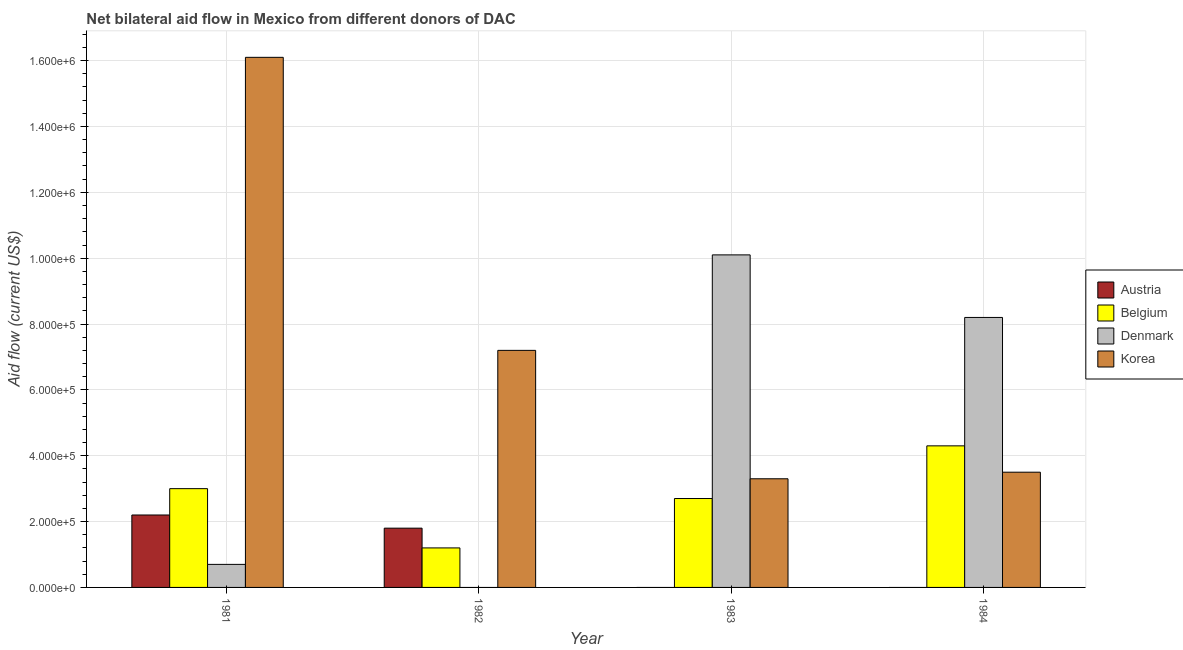How many groups of bars are there?
Provide a succinct answer. 4. Are the number of bars per tick equal to the number of legend labels?
Offer a very short reply. No. How many bars are there on the 4th tick from the right?
Provide a short and direct response. 4. In how many cases, is the number of bars for a given year not equal to the number of legend labels?
Offer a terse response. 3. Across all years, what is the maximum amount of aid given by belgium?
Make the answer very short. 4.30e+05. In which year was the amount of aid given by denmark maximum?
Give a very brief answer. 1983. What is the total amount of aid given by denmark in the graph?
Provide a short and direct response. 1.90e+06. What is the difference between the amount of aid given by korea in 1983 and that in 1984?
Your answer should be compact. -2.00e+04. What is the difference between the amount of aid given by austria in 1982 and the amount of aid given by denmark in 1984?
Offer a very short reply. 1.80e+05. What is the average amount of aid given by austria per year?
Provide a short and direct response. 1.00e+05. In how many years, is the amount of aid given by belgium greater than 600000 US$?
Ensure brevity in your answer.  0. What is the ratio of the amount of aid given by belgium in 1981 to that in 1982?
Your answer should be very brief. 2.5. What is the difference between the highest and the second highest amount of aid given by korea?
Provide a short and direct response. 8.90e+05. What is the difference between the highest and the lowest amount of aid given by denmark?
Your response must be concise. 1.01e+06. Is it the case that in every year, the sum of the amount of aid given by belgium and amount of aid given by korea is greater than the sum of amount of aid given by denmark and amount of aid given by austria?
Offer a very short reply. No. Is it the case that in every year, the sum of the amount of aid given by austria and amount of aid given by belgium is greater than the amount of aid given by denmark?
Your response must be concise. No. Are all the bars in the graph horizontal?
Provide a short and direct response. No. Does the graph contain any zero values?
Ensure brevity in your answer.  Yes. Where does the legend appear in the graph?
Give a very brief answer. Center right. What is the title of the graph?
Your answer should be compact. Net bilateral aid flow in Mexico from different donors of DAC. What is the Aid flow (current US$) of Austria in 1981?
Offer a terse response. 2.20e+05. What is the Aid flow (current US$) of Denmark in 1981?
Your response must be concise. 7.00e+04. What is the Aid flow (current US$) in Korea in 1981?
Offer a very short reply. 1.61e+06. What is the Aid flow (current US$) of Austria in 1982?
Provide a succinct answer. 1.80e+05. What is the Aid flow (current US$) of Korea in 1982?
Your answer should be compact. 7.20e+05. What is the Aid flow (current US$) in Austria in 1983?
Offer a terse response. 0. What is the Aid flow (current US$) in Belgium in 1983?
Your answer should be very brief. 2.70e+05. What is the Aid flow (current US$) in Denmark in 1983?
Your answer should be very brief. 1.01e+06. What is the Aid flow (current US$) of Korea in 1983?
Ensure brevity in your answer.  3.30e+05. What is the Aid flow (current US$) in Austria in 1984?
Your answer should be compact. 0. What is the Aid flow (current US$) in Denmark in 1984?
Give a very brief answer. 8.20e+05. What is the Aid flow (current US$) in Korea in 1984?
Make the answer very short. 3.50e+05. Across all years, what is the maximum Aid flow (current US$) of Belgium?
Provide a succinct answer. 4.30e+05. Across all years, what is the maximum Aid flow (current US$) of Denmark?
Provide a succinct answer. 1.01e+06. Across all years, what is the maximum Aid flow (current US$) in Korea?
Provide a succinct answer. 1.61e+06. Across all years, what is the minimum Aid flow (current US$) of Austria?
Your answer should be compact. 0. Across all years, what is the minimum Aid flow (current US$) in Belgium?
Offer a terse response. 1.20e+05. Across all years, what is the minimum Aid flow (current US$) of Korea?
Your answer should be very brief. 3.30e+05. What is the total Aid flow (current US$) of Austria in the graph?
Ensure brevity in your answer.  4.00e+05. What is the total Aid flow (current US$) in Belgium in the graph?
Offer a terse response. 1.12e+06. What is the total Aid flow (current US$) in Denmark in the graph?
Provide a succinct answer. 1.90e+06. What is the total Aid flow (current US$) in Korea in the graph?
Make the answer very short. 3.01e+06. What is the difference between the Aid flow (current US$) of Belgium in 1981 and that in 1982?
Ensure brevity in your answer.  1.80e+05. What is the difference between the Aid flow (current US$) in Korea in 1981 and that in 1982?
Provide a short and direct response. 8.90e+05. What is the difference between the Aid flow (current US$) in Denmark in 1981 and that in 1983?
Your answer should be very brief. -9.40e+05. What is the difference between the Aid flow (current US$) in Korea in 1981 and that in 1983?
Provide a succinct answer. 1.28e+06. What is the difference between the Aid flow (current US$) in Belgium in 1981 and that in 1984?
Offer a terse response. -1.30e+05. What is the difference between the Aid flow (current US$) of Denmark in 1981 and that in 1984?
Offer a terse response. -7.50e+05. What is the difference between the Aid flow (current US$) in Korea in 1981 and that in 1984?
Provide a succinct answer. 1.26e+06. What is the difference between the Aid flow (current US$) in Korea in 1982 and that in 1983?
Ensure brevity in your answer.  3.90e+05. What is the difference between the Aid flow (current US$) in Belgium in 1982 and that in 1984?
Ensure brevity in your answer.  -3.10e+05. What is the difference between the Aid flow (current US$) in Belgium in 1983 and that in 1984?
Your answer should be compact. -1.60e+05. What is the difference between the Aid flow (current US$) of Korea in 1983 and that in 1984?
Your answer should be very brief. -2.00e+04. What is the difference between the Aid flow (current US$) in Austria in 1981 and the Aid flow (current US$) in Korea in 1982?
Give a very brief answer. -5.00e+05. What is the difference between the Aid flow (current US$) in Belgium in 1981 and the Aid flow (current US$) in Korea in 1982?
Offer a terse response. -4.20e+05. What is the difference between the Aid flow (current US$) of Denmark in 1981 and the Aid flow (current US$) of Korea in 1982?
Offer a terse response. -6.50e+05. What is the difference between the Aid flow (current US$) in Austria in 1981 and the Aid flow (current US$) in Belgium in 1983?
Provide a succinct answer. -5.00e+04. What is the difference between the Aid flow (current US$) in Austria in 1981 and the Aid flow (current US$) in Denmark in 1983?
Your answer should be compact. -7.90e+05. What is the difference between the Aid flow (current US$) of Belgium in 1981 and the Aid flow (current US$) of Denmark in 1983?
Offer a terse response. -7.10e+05. What is the difference between the Aid flow (current US$) of Belgium in 1981 and the Aid flow (current US$) of Korea in 1983?
Give a very brief answer. -3.00e+04. What is the difference between the Aid flow (current US$) of Austria in 1981 and the Aid flow (current US$) of Denmark in 1984?
Offer a very short reply. -6.00e+05. What is the difference between the Aid flow (current US$) of Austria in 1981 and the Aid flow (current US$) of Korea in 1984?
Give a very brief answer. -1.30e+05. What is the difference between the Aid flow (current US$) in Belgium in 1981 and the Aid flow (current US$) in Denmark in 1984?
Make the answer very short. -5.20e+05. What is the difference between the Aid flow (current US$) of Denmark in 1981 and the Aid flow (current US$) of Korea in 1984?
Provide a short and direct response. -2.80e+05. What is the difference between the Aid flow (current US$) of Austria in 1982 and the Aid flow (current US$) of Belgium in 1983?
Your response must be concise. -9.00e+04. What is the difference between the Aid flow (current US$) of Austria in 1982 and the Aid flow (current US$) of Denmark in 1983?
Offer a very short reply. -8.30e+05. What is the difference between the Aid flow (current US$) in Belgium in 1982 and the Aid flow (current US$) in Denmark in 1983?
Ensure brevity in your answer.  -8.90e+05. What is the difference between the Aid flow (current US$) in Austria in 1982 and the Aid flow (current US$) in Denmark in 1984?
Your response must be concise. -6.40e+05. What is the difference between the Aid flow (current US$) in Austria in 1982 and the Aid flow (current US$) in Korea in 1984?
Make the answer very short. -1.70e+05. What is the difference between the Aid flow (current US$) in Belgium in 1982 and the Aid flow (current US$) in Denmark in 1984?
Offer a very short reply. -7.00e+05. What is the difference between the Aid flow (current US$) in Belgium in 1982 and the Aid flow (current US$) in Korea in 1984?
Your answer should be very brief. -2.30e+05. What is the difference between the Aid flow (current US$) in Belgium in 1983 and the Aid flow (current US$) in Denmark in 1984?
Provide a short and direct response. -5.50e+05. What is the difference between the Aid flow (current US$) of Belgium in 1983 and the Aid flow (current US$) of Korea in 1984?
Ensure brevity in your answer.  -8.00e+04. What is the difference between the Aid flow (current US$) of Denmark in 1983 and the Aid flow (current US$) of Korea in 1984?
Ensure brevity in your answer.  6.60e+05. What is the average Aid flow (current US$) in Austria per year?
Your answer should be compact. 1.00e+05. What is the average Aid flow (current US$) in Belgium per year?
Make the answer very short. 2.80e+05. What is the average Aid flow (current US$) in Denmark per year?
Make the answer very short. 4.75e+05. What is the average Aid flow (current US$) in Korea per year?
Provide a succinct answer. 7.52e+05. In the year 1981, what is the difference between the Aid flow (current US$) of Austria and Aid flow (current US$) of Korea?
Your answer should be very brief. -1.39e+06. In the year 1981, what is the difference between the Aid flow (current US$) in Belgium and Aid flow (current US$) in Denmark?
Your answer should be very brief. 2.30e+05. In the year 1981, what is the difference between the Aid flow (current US$) of Belgium and Aid flow (current US$) of Korea?
Ensure brevity in your answer.  -1.31e+06. In the year 1981, what is the difference between the Aid flow (current US$) in Denmark and Aid flow (current US$) in Korea?
Make the answer very short. -1.54e+06. In the year 1982, what is the difference between the Aid flow (current US$) in Austria and Aid flow (current US$) in Korea?
Your answer should be compact. -5.40e+05. In the year 1982, what is the difference between the Aid flow (current US$) in Belgium and Aid flow (current US$) in Korea?
Provide a succinct answer. -6.00e+05. In the year 1983, what is the difference between the Aid flow (current US$) in Belgium and Aid flow (current US$) in Denmark?
Offer a very short reply. -7.40e+05. In the year 1983, what is the difference between the Aid flow (current US$) in Belgium and Aid flow (current US$) in Korea?
Provide a short and direct response. -6.00e+04. In the year 1983, what is the difference between the Aid flow (current US$) of Denmark and Aid flow (current US$) of Korea?
Provide a succinct answer. 6.80e+05. In the year 1984, what is the difference between the Aid flow (current US$) of Belgium and Aid flow (current US$) of Denmark?
Your response must be concise. -3.90e+05. In the year 1984, what is the difference between the Aid flow (current US$) in Belgium and Aid flow (current US$) in Korea?
Offer a terse response. 8.00e+04. In the year 1984, what is the difference between the Aid flow (current US$) of Denmark and Aid flow (current US$) of Korea?
Provide a short and direct response. 4.70e+05. What is the ratio of the Aid flow (current US$) in Austria in 1981 to that in 1982?
Your answer should be compact. 1.22. What is the ratio of the Aid flow (current US$) in Belgium in 1981 to that in 1982?
Give a very brief answer. 2.5. What is the ratio of the Aid flow (current US$) of Korea in 1981 to that in 1982?
Give a very brief answer. 2.24. What is the ratio of the Aid flow (current US$) in Belgium in 1981 to that in 1983?
Offer a very short reply. 1.11. What is the ratio of the Aid flow (current US$) of Denmark in 1981 to that in 1983?
Make the answer very short. 0.07. What is the ratio of the Aid flow (current US$) in Korea in 1981 to that in 1983?
Keep it short and to the point. 4.88. What is the ratio of the Aid flow (current US$) in Belgium in 1981 to that in 1984?
Your answer should be compact. 0.7. What is the ratio of the Aid flow (current US$) in Denmark in 1981 to that in 1984?
Your response must be concise. 0.09. What is the ratio of the Aid flow (current US$) in Belgium in 1982 to that in 1983?
Give a very brief answer. 0.44. What is the ratio of the Aid flow (current US$) in Korea in 1982 to that in 1983?
Ensure brevity in your answer.  2.18. What is the ratio of the Aid flow (current US$) of Belgium in 1982 to that in 1984?
Make the answer very short. 0.28. What is the ratio of the Aid flow (current US$) in Korea in 1982 to that in 1984?
Your answer should be compact. 2.06. What is the ratio of the Aid flow (current US$) in Belgium in 1983 to that in 1984?
Offer a terse response. 0.63. What is the ratio of the Aid flow (current US$) of Denmark in 1983 to that in 1984?
Provide a succinct answer. 1.23. What is the ratio of the Aid flow (current US$) in Korea in 1983 to that in 1984?
Offer a terse response. 0.94. What is the difference between the highest and the second highest Aid flow (current US$) of Korea?
Your response must be concise. 8.90e+05. What is the difference between the highest and the lowest Aid flow (current US$) in Denmark?
Give a very brief answer. 1.01e+06. What is the difference between the highest and the lowest Aid flow (current US$) in Korea?
Make the answer very short. 1.28e+06. 